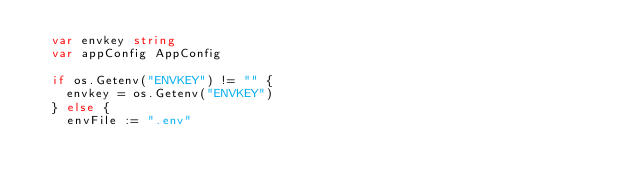Convert code to text. <code><loc_0><loc_0><loc_500><loc_500><_Go_>	var envkey string
	var appConfig AppConfig

	if os.Getenv("ENVKEY") != "" {
		envkey = os.Getenv("ENVKEY")
	} else {
		envFile := ".env"</code> 